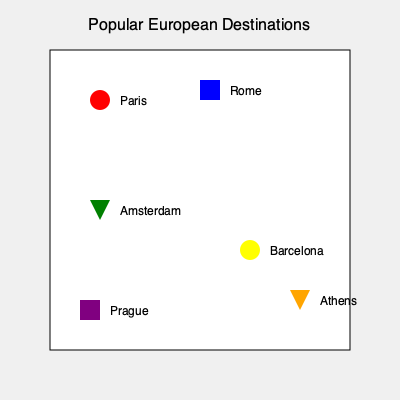You're planning a whirlwind tour of Europe and want to visit as many popular destinations as possible. According to the map, which city is represented by a yellow circle and might offer the perfect blend of beach and culture to satisfy your FOMO? To answer this question, let's analyze the map step-by-step:

1. The map shows six popular European destinations, each represented by a different shape and color.

2. The shapes used are:
   - Circles
   - Squares (rectangles)
   - Triangles

3. The colors used are:
   - Red
   - Blue
   - Green
   - Yellow
   - Purple
   - Orange

4. The question specifically asks about a city represented by a yellow circle.

5. Looking at the map, we can see that there is only one yellow circle.

6. This yellow circle is located in the lower right quadrant of the map.

7. The city name next to this yellow circle is Barcelona.

8. Barcelona is indeed known for its blend of beach and culture, making it a popular destination for travelers with FOMO (Fear of Missing Out).

Therefore, the city represented by a yellow circle on the map is Barcelona.
Answer: Barcelona 